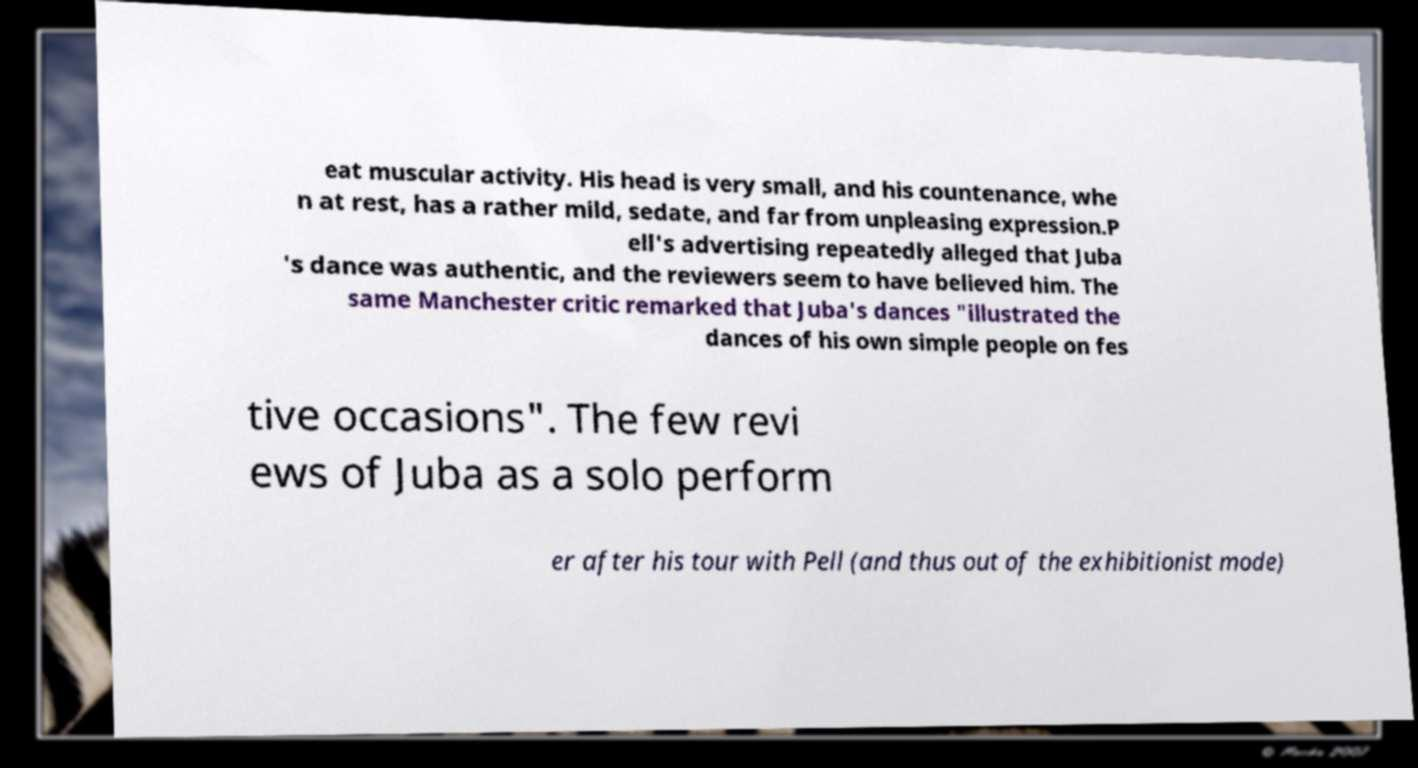Can you accurately transcribe the text from the provided image for me? eat muscular activity. His head is very small, and his countenance, whe n at rest, has a rather mild, sedate, and far from unpleasing expression.P ell's advertising repeatedly alleged that Juba 's dance was authentic, and the reviewers seem to have believed him. The same Manchester critic remarked that Juba's dances "illustrated the dances of his own simple people on fes tive occasions". The few revi ews of Juba as a solo perform er after his tour with Pell (and thus out of the exhibitionist mode) 